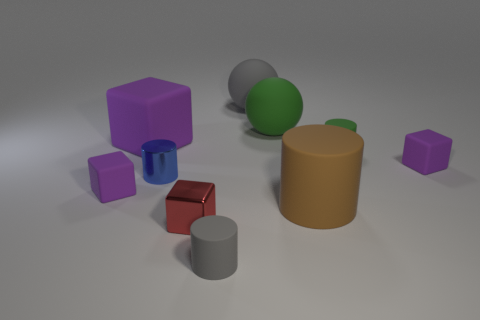Are there any purple things to the right of the large gray matte ball?
Give a very brief answer. Yes. Are there fewer big matte cubes that are right of the small gray cylinder than large green spheres?
Offer a very short reply. Yes. What is the small blue cylinder made of?
Offer a terse response. Metal. The metallic cylinder is what color?
Provide a succinct answer. Blue. What is the color of the cylinder that is right of the large gray rubber thing and on the left side of the tiny green cylinder?
Your answer should be very brief. Brown. Are the brown cylinder and the small blue cylinder behind the large brown rubber object made of the same material?
Make the answer very short. No. How big is the red metal cube in front of the purple matte object right of the large cylinder?
Keep it short and to the point. Small. Is there anything else that is the same color as the shiny block?
Provide a short and direct response. No. Is the material of the gray thing on the right side of the small gray rubber cylinder the same as the small purple block that is on the right side of the small red cube?
Your answer should be very brief. Yes. What material is the tiny cylinder that is on the right side of the tiny blue metallic cylinder and to the left of the large matte cylinder?
Offer a terse response. Rubber. 